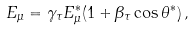Convert formula to latex. <formula><loc_0><loc_0><loc_500><loc_500>E _ { \mu } = \gamma _ { \tau } E ^ { * } _ { \mu } ( 1 + \beta _ { \tau } \cos { \theta ^ { * } } ) \, ,</formula> 